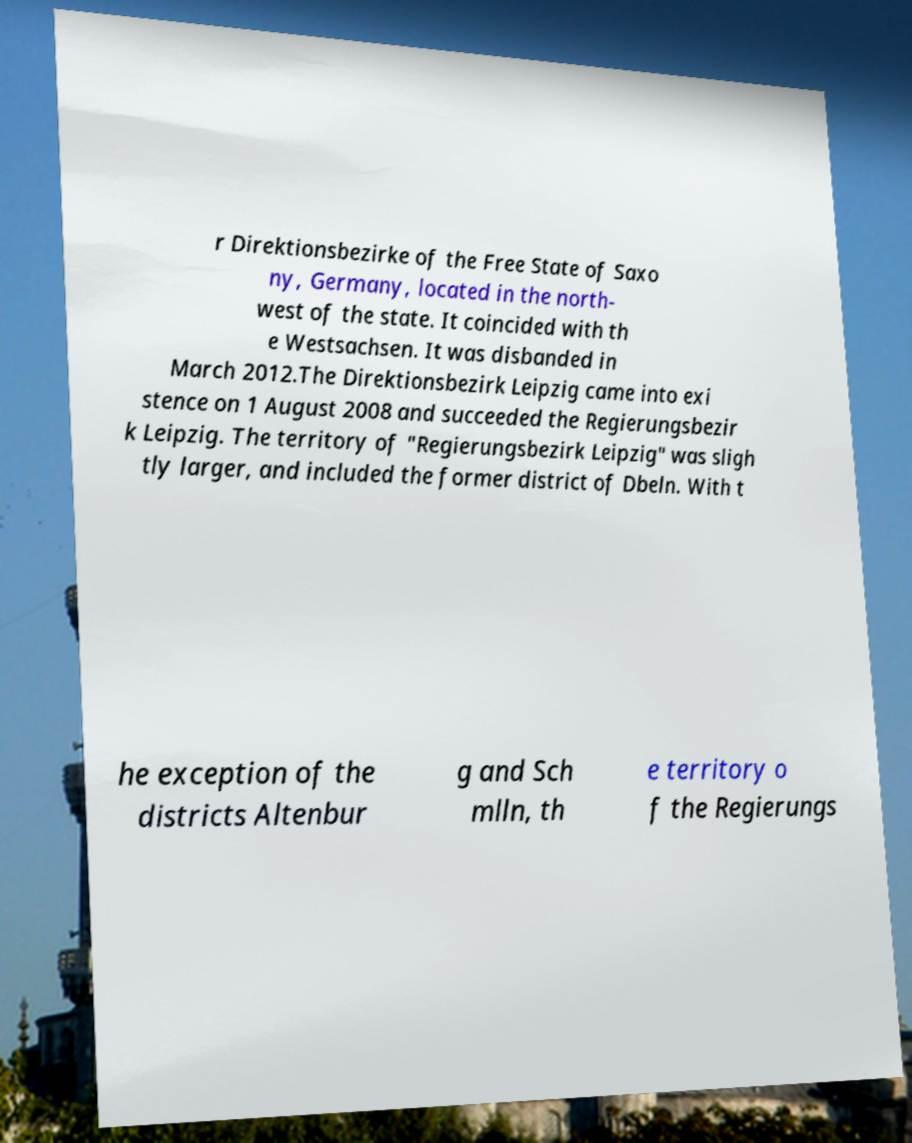I need the written content from this picture converted into text. Can you do that? r Direktionsbezirke of the Free State of Saxo ny, Germany, located in the north- west of the state. It coincided with th e Westsachsen. It was disbanded in March 2012.The Direktionsbezirk Leipzig came into exi stence on 1 August 2008 and succeeded the Regierungsbezir k Leipzig. The territory of "Regierungsbezirk Leipzig" was sligh tly larger, and included the former district of Dbeln. With t he exception of the districts Altenbur g and Sch mlln, th e territory o f the Regierungs 